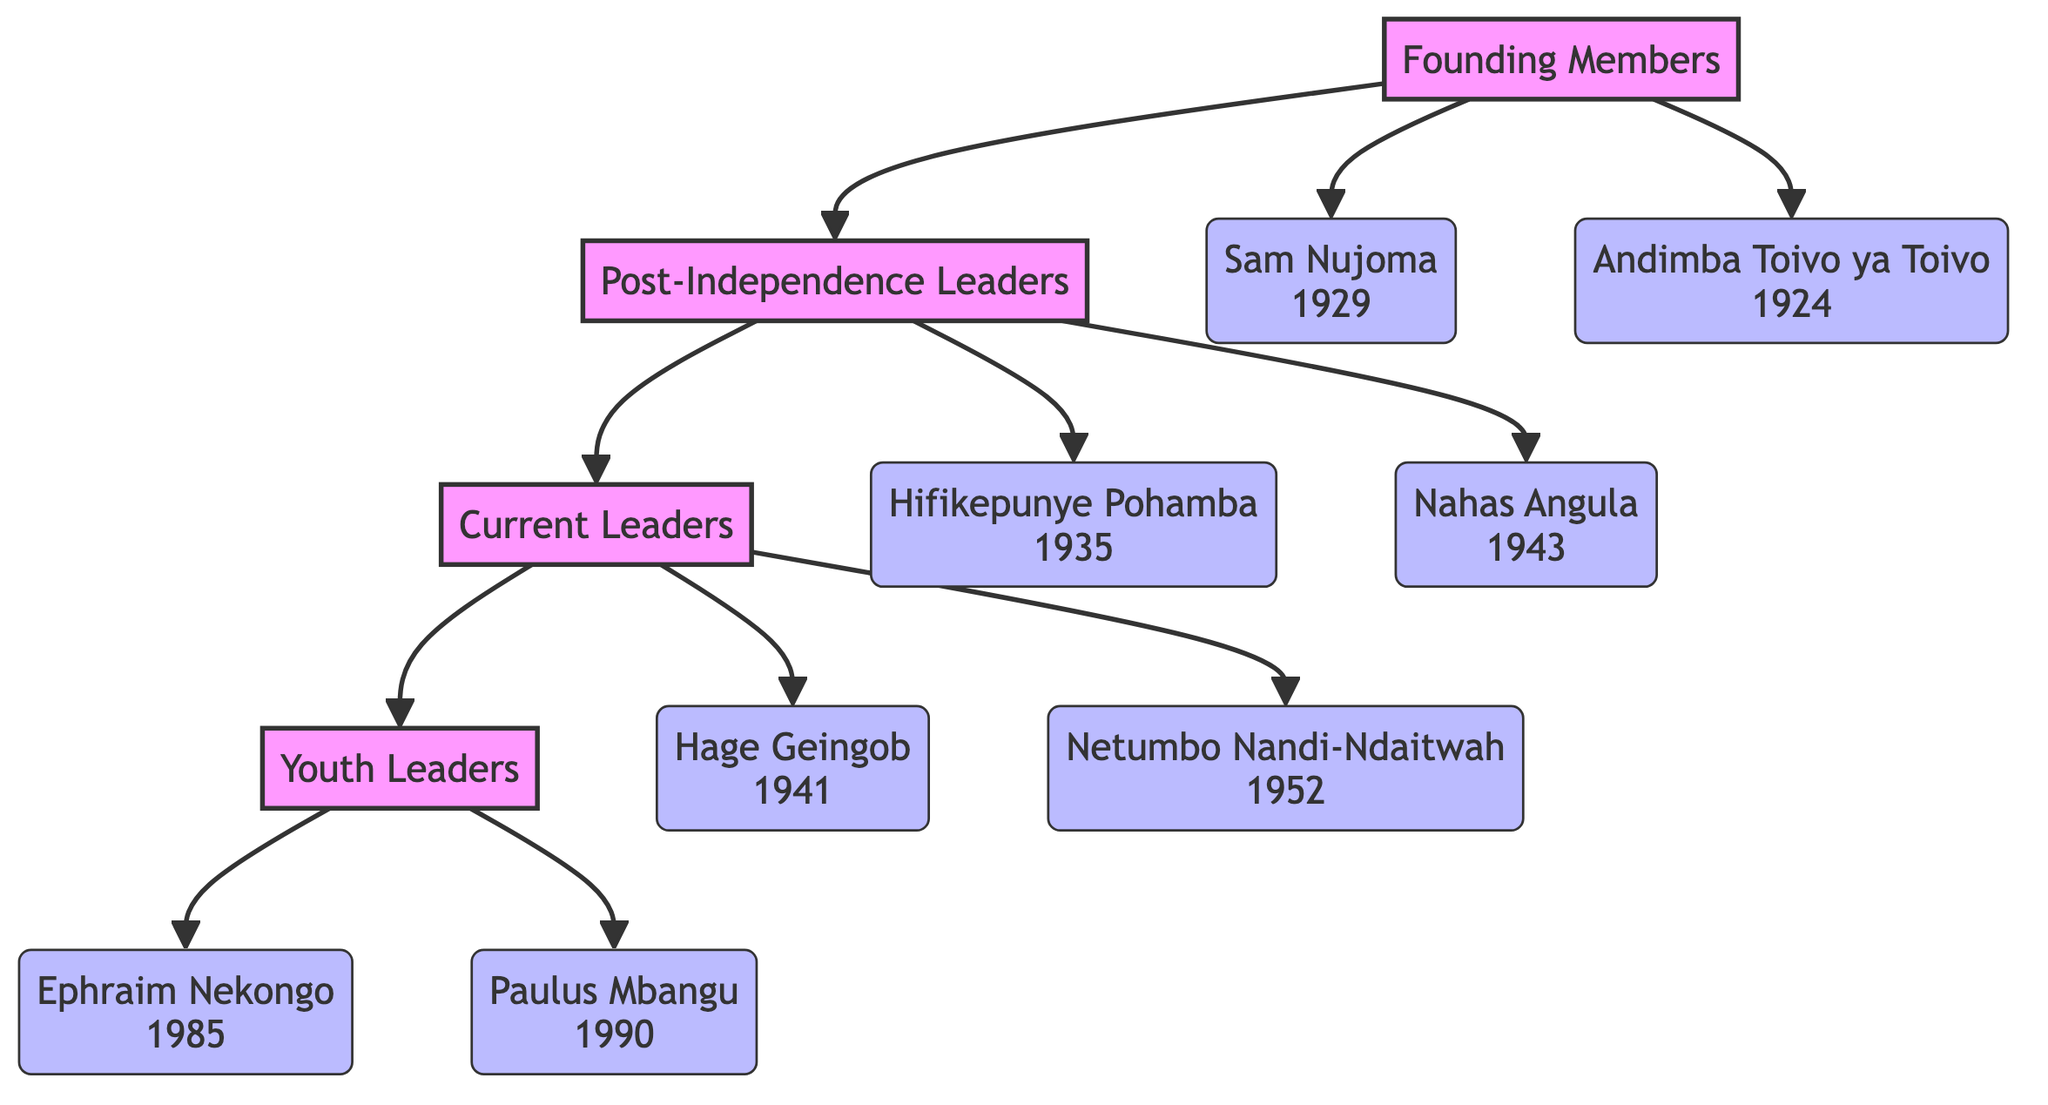What is the highest generation in the family tree? The family tree consists of four generations: Founding Members, Post-Independence Leaders, Current Leaders, and Youth Leaders. The highest generation refers to the first one listed, which is Founding Members.
Answer: Founding Members Who is the only female member in the current leaders' generation? In the Current Leaders generation, the members are Hage Geingob and Netumbo Nandi-Ndaitwah. Among these, Netumbo Nandi-Ndaitwah is the only female member.
Answer: Netumbo Nandi-Ndaitwah How many youth leaders are represented in the family tree? The Youth Leaders generation consists of two members: Ephraim Nekongo and Paulus Mbangu. Therefore, the total number of youth leaders represented is two.
Answer: 2 Who is the founding father of the SWAPO Party? In the Founding Members generation, Sam Nujoma is noted as the First President and Founding Father of SWAPO, making him the founding figure of the party.
Answer: Sam Nujoma Which generation follows the Post-Independence Leaders? The family tree structure indicates that the generation following Post-Independence Leaders is Current Leaders. This is a direct relationship shown in the diagram.
Answer: Current Leaders What is the birth year of Hifikepunye Pohamba? The data provides information that Hifikepunye Pohamba was born in 1935, as stated directly in his member profile.
Answer: 1935 Who has the role of Deputy Prime Minister in the current leaders? Among the Current Leaders, Netumbo Nandi-Ndaitwah holds the title of Deputy Prime Minister, as indicated in her member details.
Answer: Netumbo Nandi-Ndaitwah Which member was born in the year 1990? The Youth Leaders category lists Paulus Mbangu, who is specifically noted to have been born in 1990.
Answer: Paulus Mbangu In which generation is Nahas Angula categorized? The diagram categorizes Nahas Angula under the Post-Independence Leaders generation, as evident from his placement within that section.
Answer: Post-Independence Leaders 